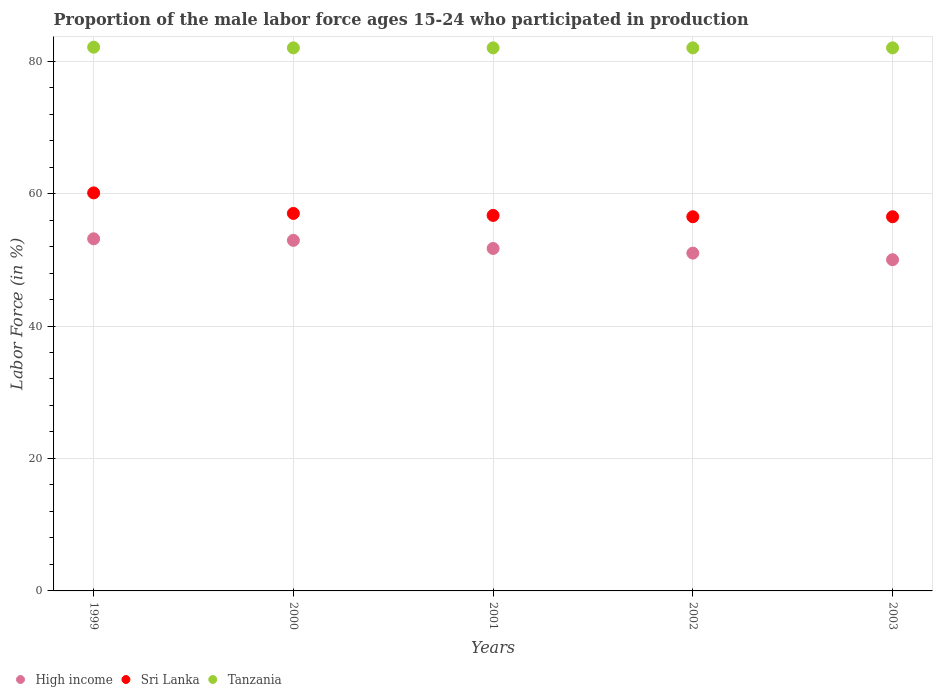Is the number of dotlines equal to the number of legend labels?
Keep it short and to the point. Yes. What is the proportion of the male labor force who participated in production in Tanzania in 2000?
Your answer should be compact. 82. Across all years, what is the maximum proportion of the male labor force who participated in production in Sri Lanka?
Provide a short and direct response. 60.1. Across all years, what is the minimum proportion of the male labor force who participated in production in Sri Lanka?
Ensure brevity in your answer.  56.5. In which year was the proportion of the male labor force who participated in production in Tanzania maximum?
Keep it short and to the point. 1999. In which year was the proportion of the male labor force who participated in production in Tanzania minimum?
Your response must be concise. 2000. What is the total proportion of the male labor force who participated in production in Tanzania in the graph?
Make the answer very short. 410.1. What is the difference between the proportion of the male labor force who participated in production in Sri Lanka in 2002 and the proportion of the male labor force who participated in production in High income in 2001?
Your answer should be compact. 4.79. What is the average proportion of the male labor force who participated in production in High income per year?
Offer a terse response. 51.77. What is the ratio of the proportion of the male labor force who participated in production in Tanzania in 2002 to that in 2003?
Offer a very short reply. 1. Is the proportion of the male labor force who participated in production in High income in 2001 less than that in 2003?
Provide a short and direct response. No. What is the difference between the highest and the second highest proportion of the male labor force who participated in production in High income?
Provide a short and direct response. 0.23. What is the difference between the highest and the lowest proportion of the male labor force who participated in production in High income?
Provide a succinct answer. 3.16. How many dotlines are there?
Your response must be concise. 3. Does the graph contain any zero values?
Give a very brief answer. No. What is the title of the graph?
Provide a short and direct response. Proportion of the male labor force ages 15-24 who participated in production. What is the label or title of the X-axis?
Offer a terse response. Years. What is the Labor Force (in %) of High income in 1999?
Give a very brief answer. 53.17. What is the Labor Force (in %) of Sri Lanka in 1999?
Provide a succinct answer. 60.1. What is the Labor Force (in %) in Tanzania in 1999?
Ensure brevity in your answer.  82.1. What is the Labor Force (in %) of High income in 2000?
Ensure brevity in your answer.  52.93. What is the Labor Force (in %) of Tanzania in 2000?
Give a very brief answer. 82. What is the Labor Force (in %) of High income in 2001?
Your answer should be very brief. 51.71. What is the Labor Force (in %) of Sri Lanka in 2001?
Your answer should be compact. 56.7. What is the Labor Force (in %) in High income in 2002?
Your answer should be very brief. 51.01. What is the Labor Force (in %) of Sri Lanka in 2002?
Keep it short and to the point. 56.5. What is the Labor Force (in %) of High income in 2003?
Offer a terse response. 50.01. What is the Labor Force (in %) in Sri Lanka in 2003?
Provide a succinct answer. 56.5. What is the Labor Force (in %) of Tanzania in 2003?
Keep it short and to the point. 82. Across all years, what is the maximum Labor Force (in %) of High income?
Make the answer very short. 53.17. Across all years, what is the maximum Labor Force (in %) in Sri Lanka?
Offer a very short reply. 60.1. Across all years, what is the maximum Labor Force (in %) in Tanzania?
Offer a very short reply. 82.1. Across all years, what is the minimum Labor Force (in %) in High income?
Your answer should be very brief. 50.01. Across all years, what is the minimum Labor Force (in %) in Sri Lanka?
Offer a terse response. 56.5. Across all years, what is the minimum Labor Force (in %) of Tanzania?
Make the answer very short. 82. What is the total Labor Force (in %) of High income in the graph?
Offer a terse response. 258.83. What is the total Labor Force (in %) of Sri Lanka in the graph?
Your answer should be compact. 286.8. What is the total Labor Force (in %) of Tanzania in the graph?
Keep it short and to the point. 410.1. What is the difference between the Labor Force (in %) of High income in 1999 and that in 2000?
Keep it short and to the point. 0.23. What is the difference between the Labor Force (in %) of Sri Lanka in 1999 and that in 2000?
Ensure brevity in your answer.  3.1. What is the difference between the Labor Force (in %) of Tanzania in 1999 and that in 2000?
Your response must be concise. 0.1. What is the difference between the Labor Force (in %) of High income in 1999 and that in 2001?
Give a very brief answer. 1.46. What is the difference between the Labor Force (in %) in High income in 1999 and that in 2002?
Make the answer very short. 2.16. What is the difference between the Labor Force (in %) of High income in 1999 and that in 2003?
Give a very brief answer. 3.16. What is the difference between the Labor Force (in %) in Sri Lanka in 1999 and that in 2003?
Offer a terse response. 3.6. What is the difference between the Labor Force (in %) in Tanzania in 1999 and that in 2003?
Provide a succinct answer. 0.1. What is the difference between the Labor Force (in %) in High income in 2000 and that in 2001?
Offer a terse response. 1.23. What is the difference between the Labor Force (in %) of High income in 2000 and that in 2002?
Your answer should be very brief. 1.93. What is the difference between the Labor Force (in %) in Sri Lanka in 2000 and that in 2002?
Offer a very short reply. 0.5. What is the difference between the Labor Force (in %) of High income in 2000 and that in 2003?
Your response must be concise. 2.92. What is the difference between the Labor Force (in %) in Tanzania in 2000 and that in 2003?
Your answer should be compact. 0. What is the difference between the Labor Force (in %) in High income in 2001 and that in 2002?
Your answer should be compact. 0.7. What is the difference between the Labor Force (in %) of Tanzania in 2001 and that in 2002?
Keep it short and to the point. 0. What is the difference between the Labor Force (in %) in High income in 2001 and that in 2003?
Your response must be concise. 1.7. What is the difference between the Labor Force (in %) in Tanzania in 2001 and that in 2003?
Offer a terse response. 0. What is the difference between the Labor Force (in %) of Sri Lanka in 2002 and that in 2003?
Give a very brief answer. 0. What is the difference between the Labor Force (in %) of Tanzania in 2002 and that in 2003?
Keep it short and to the point. 0. What is the difference between the Labor Force (in %) in High income in 1999 and the Labor Force (in %) in Sri Lanka in 2000?
Your answer should be very brief. -3.83. What is the difference between the Labor Force (in %) of High income in 1999 and the Labor Force (in %) of Tanzania in 2000?
Make the answer very short. -28.83. What is the difference between the Labor Force (in %) in Sri Lanka in 1999 and the Labor Force (in %) in Tanzania in 2000?
Offer a very short reply. -21.9. What is the difference between the Labor Force (in %) of High income in 1999 and the Labor Force (in %) of Sri Lanka in 2001?
Give a very brief answer. -3.53. What is the difference between the Labor Force (in %) of High income in 1999 and the Labor Force (in %) of Tanzania in 2001?
Your response must be concise. -28.83. What is the difference between the Labor Force (in %) of Sri Lanka in 1999 and the Labor Force (in %) of Tanzania in 2001?
Offer a very short reply. -21.9. What is the difference between the Labor Force (in %) of High income in 1999 and the Labor Force (in %) of Sri Lanka in 2002?
Keep it short and to the point. -3.33. What is the difference between the Labor Force (in %) of High income in 1999 and the Labor Force (in %) of Tanzania in 2002?
Offer a terse response. -28.83. What is the difference between the Labor Force (in %) of Sri Lanka in 1999 and the Labor Force (in %) of Tanzania in 2002?
Offer a terse response. -21.9. What is the difference between the Labor Force (in %) in High income in 1999 and the Labor Force (in %) in Sri Lanka in 2003?
Offer a terse response. -3.33. What is the difference between the Labor Force (in %) in High income in 1999 and the Labor Force (in %) in Tanzania in 2003?
Offer a very short reply. -28.83. What is the difference between the Labor Force (in %) of Sri Lanka in 1999 and the Labor Force (in %) of Tanzania in 2003?
Ensure brevity in your answer.  -21.9. What is the difference between the Labor Force (in %) in High income in 2000 and the Labor Force (in %) in Sri Lanka in 2001?
Give a very brief answer. -3.77. What is the difference between the Labor Force (in %) in High income in 2000 and the Labor Force (in %) in Tanzania in 2001?
Provide a short and direct response. -29.07. What is the difference between the Labor Force (in %) of Sri Lanka in 2000 and the Labor Force (in %) of Tanzania in 2001?
Your response must be concise. -25. What is the difference between the Labor Force (in %) in High income in 2000 and the Labor Force (in %) in Sri Lanka in 2002?
Your answer should be compact. -3.57. What is the difference between the Labor Force (in %) in High income in 2000 and the Labor Force (in %) in Tanzania in 2002?
Make the answer very short. -29.07. What is the difference between the Labor Force (in %) of High income in 2000 and the Labor Force (in %) of Sri Lanka in 2003?
Your response must be concise. -3.57. What is the difference between the Labor Force (in %) of High income in 2000 and the Labor Force (in %) of Tanzania in 2003?
Your answer should be very brief. -29.07. What is the difference between the Labor Force (in %) of Sri Lanka in 2000 and the Labor Force (in %) of Tanzania in 2003?
Your answer should be compact. -25. What is the difference between the Labor Force (in %) of High income in 2001 and the Labor Force (in %) of Sri Lanka in 2002?
Provide a succinct answer. -4.79. What is the difference between the Labor Force (in %) of High income in 2001 and the Labor Force (in %) of Tanzania in 2002?
Provide a succinct answer. -30.29. What is the difference between the Labor Force (in %) in Sri Lanka in 2001 and the Labor Force (in %) in Tanzania in 2002?
Your answer should be compact. -25.3. What is the difference between the Labor Force (in %) of High income in 2001 and the Labor Force (in %) of Sri Lanka in 2003?
Ensure brevity in your answer.  -4.79. What is the difference between the Labor Force (in %) in High income in 2001 and the Labor Force (in %) in Tanzania in 2003?
Provide a short and direct response. -30.29. What is the difference between the Labor Force (in %) in Sri Lanka in 2001 and the Labor Force (in %) in Tanzania in 2003?
Offer a terse response. -25.3. What is the difference between the Labor Force (in %) of High income in 2002 and the Labor Force (in %) of Sri Lanka in 2003?
Your answer should be very brief. -5.49. What is the difference between the Labor Force (in %) in High income in 2002 and the Labor Force (in %) in Tanzania in 2003?
Your answer should be compact. -30.99. What is the difference between the Labor Force (in %) in Sri Lanka in 2002 and the Labor Force (in %) in Tanzania in 2003?
Keep it short and to the point. -25.5. What is the average Labor Force (in %) of High income per year?
Offer a terse response. 51.77. What is the average Labor Force (in %) in Sri Lanka per year?
Your answer should be very brief. 57.36. What is the average Labor Force (in %) in Tanzania per year?
Give a very brief answer. 82.02. In the year 1999, what is the difference between the Labor Force (in %) of High income and Labor Force (in %) of Sri Lanka?
Provide a short and direct response. -6.93. In the year 1999, what is the difference between the Labor Force (in %) of High income and Labor Force (in %) of Tanzania?
Provide a succinct answer. -28.93. In the year 2000, what is the difference between the Labor Force (in %) in High income and Labor Force (in %) in Sri Lanka?
Offer a terse response. -4.07. In the year 2000, what is the difference between the Labor Force (in %) in High income and Labor Force (in %) in Tanzania?
Your answer should be compact. -29.07. In the year 2001, what is the difference between the Labor Force (in %) in High income and Labor Force (in %) in Sri Lanka?
Provide a short and direct response. -4.99. In the year 2001, what is the difference between the Labor Force (in %) in High income and Labor Force (in %) in Tanzania?
Offer a terse response. -30.29. In the year 2001, what is the difference between the Labor Force (in %) of Sri Lanka and Labor Force (in %) of Tanzania?
Provide a short and direct response. -25.3. In the year 2002, what is the difference between the Labor Force (in %) of High income and Labor Force (in %) of Sri Lanka?
Offer a terse response. -5.49. In the year 2002, what is the difference between the Labor Force (in %) of High income and Labor Force (in %) of Tanzania?
Keep it short and to the point. -30.99. In the year 2002, what is the difference between the Labor Force (in %) in Sri Lanka and Labor Force (in %) in Tanzania?
Provide a short and direct response. -25.5. In the year 2003, what is the difference between the Labor Force (in %) in High income and Labor Force (in %) in Sri Lanka?
Provide a short and direct response. -6.49. In the year 2003, what is the difference between the Labor Force (in %) in High income and Labor Force (in %) in Tanzania?
Keep it short and to the point. -31.99. In the year 2003, what is the difference between the Labor Force (in %) in Sri Lanka and Labor Force (in %) in Tanzania?
Offer a very short reply. -25.5. What is the ratio of the Labor Force (in %) in Sri Lanka in 1999 to that in 2000?
Provide a succinct answer. 1.05. What is the ratio of the Labor Force (in %) in Tanzania in 1999 to that in 2000?
Your answer should be very brief. 1. What is the ratio of the Labor Force (in %) in High income in 1999 to that in 2001?
Ensure brevity in your answer.  1.03. What is the ratio of the Labor Force (in %) of Sri Lanka in 1999 to that in 2001?
Your answer should be compact. 1.06. What is the ratio of the Labor Force (in %) of High income in 1999 to that in 2002?
Ensure brevity in your answer.  1.04. What is the ratio of the Labor Force (in %) of Sri Lanka in 1999 to that in 2002?
Your response must be concise. 1.06. What is the ratio of the Labor Force (in %) of High income in 1999 to that in 2003?
Your answer should be compact. 1.06. What is the ratio of the Labor Force (in %) in Sri Lanka in 1999 to that in 2003?
Offer a very short reply. 1.06. What is the ratio of the Labor Force (in %) in Tanzania in 1999 to that in 2003?
Offer a terse response. 1. What is the ratio of the Labor Force (in %) of High income in 2000 to that in 2001?
Give a very brief answer. 1.02. What is the ratio of the Labor Force (in %) of High income in 2000 to that in 2002?
Your answer should be very brief. 1.04. What is the ratio of the Labor Force (in %) of Sri Lanka in 2000 to that in 2002?
Your answer should be very brief. 1.01. What is the ratio of the Labor Force (in %) in High income in 2000 to that in 2003?
Provide a succinct answer. 1.06. What is the ratio of the Labor Force (in %) of Sri Lanka in 2000 to that in 2003?
Provide a short and direct response. 1.01. What is the ratio of the Labor Force (in %) of High income in 2001 to that in 2002?
Provide a short and direct response. 1.01. What is the ratio of the Labor Force (in %) of Sri Lanka in 2001 to that in 2002?
Provide a short and direct response. 1. What is the ratio of the Labor Force (in %) in Tanzania in 2001 to that in 2002?
Provide a short and direct response. 1. What is the ratio of the Labor Force (in %) of High income in 2001 to that in 2003?
Ensure brevity in your answer.  1.03. What is the ratio of the Labor Force (in %) in Sri Lanka in 2001 to that in 2003?
Provide a succinct answer. 1. What is the ratio of the Labor Force (in %) in Tanzania in 2001 to that in 2003?
Your answer should be very brief. 1. What is the ratio of the Labor Force (in %) of High income in 2002 to that in 2003?
Offer a very short reply. 1.02. What is the difference between the highest and the second highest Labor Force (in %) in High income?
Provide a short and direct response. 0.23. What is the difference between the highest and the second highest Labor Force (in %) in Tanzania?
Ensure brevity in your answer.  0.1. What is the difference between the highest and the lowest Labor Force (in %) in High income?
Keep it short and to the point. 3.16. 